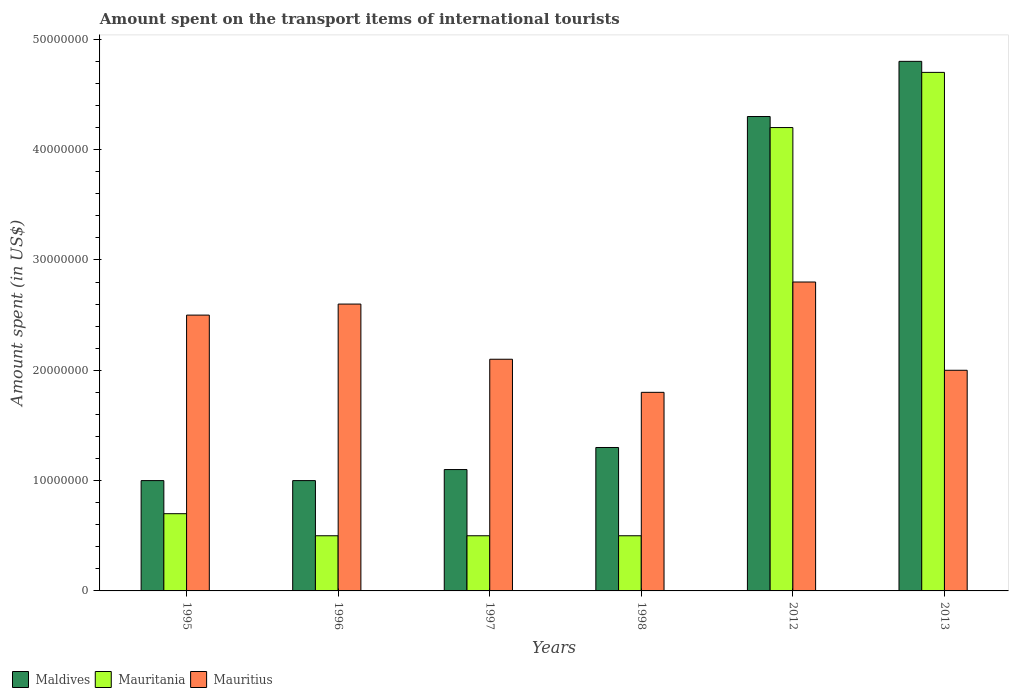Are the number of bars per tick equal to the number of legend labels?
Offer a terse response. Yes. Are the number of bars on each tick of the X-axis equal?
Make the answer very short. Yes. How many bars are there on the 2nd tick from the left?
Keep it short and to the point. 3. How many bars are there on the 3rd tick from the right?
Keep it short and to the point. 3. What is the label of the 5th group of bars from the left?
Your response must be concise. 2012. In how many cases, is the number of bars for a given year not equal to the number of legend labels?
Your answer should be compact. 0. What is the amount spent on the transport items of international tourists in Maldives in 2012?
Offer a terse response. 4.30e+07. Across all years, what is the maximum amount spent on the transport items of international tourists in Mauritius?
Provide a succinct answer. 2.80e+07. In which year was the amount spent on the transport items of international tourists in Mauritania maximum?
Your answer should be compact. 2013. In which year was the amount spent on the transport items of international tourists in Mauritania minimum?
Give a very brief answer. 1996. What is the total amount spent on the transport items of international tourists in Maldives in the graph?
Ensure brevity in your answer.  1.35e+08. What is the difference between the amount spent on the transport items of international tourists in Mauritania in 1998 and that in 2013?
Offer a terse response. -4.20e+07. What is the difference between the amount spent on the transport items of international tourists in Maldives in 2012 and the amount spent on the transport items of international tourists in Mauritius in 1995?
Your response must be concise. 1.80e+07. What is the average amount spent on the transport items of international tourists in Mauritania per year?
Keep it short and to the point. 1.85e+07. In the year 1995, what is the difference between the amount spent on the transport items of international tourists in Maldives and amount spent on the transport items of international tourists in Mauritius?
Make the answer very short. -1.50e+07. In how many years, is the amount spent on the transport items of international tourists in Maldives greater than 16000000 US$?
Your answer should be compact. 2. What is the ratio of the amount spent on the transport items of international tourists in Mauritania in 1996 to that in 2013?
Your answer should be compact. 0.11. Is the amount spent on the transport items of international tourists in Mauritania in 1995 less than that in 1996?
Give a very brief answer. No. What is the difference between the highest and the second highest amount spent on the transport items of international tourists in Mauritania?
Provide a short and direct response. 5.00e+06. What is the difference between the highest and the lowest amount spent on the transport items of international tourists in Mauritius?
Your answer should be compact. 1.00e+07. In how many years, is the amount spent on the transport items of international tourists in Mauritius greater than the average amount spent on the transport items of international tourists in Mauritius taken over all years?
Make the answer very short. 3. Is the sum of the amount spent on the transport items of international tourists in Mauritius in 1996 and 1997 greater than the maximum amount spent on the transport items of international tourists in Maldives across all years?
Your answer should be very brief. No. What does the 1st bar from the left in 1996 represents?
Your answer should be compact. Maldives. What does the 3rd bar from the right in 1995 represents?
Provide a short and direct response. Maldives. How many bars are there?
Provide a short and direct response. 18. What is the difference between two consecutive major ticks on the Y-axis?
Your answer should be very brief. 1.00e+07. Does the graph contain any zero values?
Make the answer very short. No. Does the graph contain grids?
Provide a short and direct response. No. Where does the legend appear in the graph?
Offer a very short reply. Bottom left. What is the title of the graph?
Offer a terse response. Amount spent on the transport items of international tourists. Does "Kenya" appear as one of the legend labels in the graph?
Give a very brief answer. No. What is the label or title of the X-axis?
Provide a succinct answer. Years. What is the label or title of the Y-axis?
Your response must be concise. Amount spent (in US$). What is the Amount spent (in US$) of Mauritius in 1995?
Your answer should be very brief. 2.50e+07. What is the Amount spent (in US$) of Maldives in 1996?
Make the answer very short. 1.00e+07. What is the Amount spent (in US$) of Mauritania in 1996?
Provide a succinct answer. 5.00e+06. What is the Amount spent (in US$) of Mauritius in 1996?
Keep it short and to the point. 2.60e+07. What is the Amount spent (in US$) in Maldives in 1997?
Offer a terse response. 1.10e+07. What is the Amount spent (in US$) of Mauritania in 1997?
Your response must be concise. 5.00e+06. What is the Amount spent (in US$) of Mauritius in 1997?
Offer a very short reply. 2.10e+07. What is the Amount spent (in US$) of Maldives in 1998?
Ensure brevity in your answer.  1.30e+07. What is the Amount spent (in US$) in Mauritania in 1998?
Make the answer very short. 5.00e+06. What is the Amount spent (in US$) in Mauritius in 1998?
Your answer should be very brief. 1.80e+07. What is the Amount spent (in US$) of Maldives in 2012?
Your answer should be very brief. 4.30e+07. What is the Amount spent (in US$) in Mauritania in 2012?
Your answer should be very brief. 4.20e+07. What is the Amount spent (in US$) in Mauritius in 2012?
Provide a succinct answer. 2.80e+07. What is the Amount spent (in US$) of Maldives in 2013?
Make the answer very short. 4.80e+07. What is the Amount spent (in US$) of Mauritania in 2013?
Keep it short and to the point. 4.70e+07. Across all years, what is the maximum Amount spent (in US$) in Maldives?
Ensure brevity in your answer.  4.80e+07. Across all years, what is the maximum Amount spent (in US$) in Mauritania?
Provide a short and direct response. 4.70e+07. Across all years, what is the maximum Amount spent (in US$) of Mauritius?
Give a very brief answer. 2.80e+07. Across all years, what is the minimum Amount spent (in US$) of Mauritius?
Offer a very short reply. 1.80e+07. What is the total Amount spent (in US$) in Maldives in the graph?
Keep it short and to the point. 1.35e+08. What is the total Amount spent (in US$) in Mauritania in the graph?
Keep it short and to the point. 1.11e+08. What is the total Amount spent (in US$) of Mauritius in the graph?
Your answer should be very brief. 1.38e+08. What is the difference between the Amount spent (in US$) of Maldives in 1995 and that in 1996?
Your answer should be compact. 0. What is the difference between the Amount spent (in US$) of Mauritania in 1995 and that in 1996?
Your answer should be very brief. 2.00e+06. What is the difference between the Amount spent (in US$) of Mauritius in 1995 and that in 1996?
Offer a very short reply. -1.00e+06. What is the difference between the Amount spent (in US$) in Mauritania in 1995 and that in 1997?
Offer a very short reply. 2.00e+06. What is the difference between the Amount spent (in US$) in Mauritius in 1995 and that in 1997?
Provide a succinct answer. 4.00e+06. What is the difference between the Amount spent (in US$) of Maldives in 1995 and that in 2012?
Your answer should be very brief. -3.30e+07. What is the difference between the Amount spent (in US$) of Mauritania in 1995 and that in 2012?
Provide a succinct answer. -3.50e+07. What is the difference between the Amount spent (in US$) of Mauritius in 1995 and that in 2012?
Your answer should be compact. -3.00e+06. What is the difference between the Amount spent (in US$) of Maldives in 1995 and that in 2013?
Give a very brief answer. -3.80e+07. What is the difference between the Amount spent (in US$) of Mauritania in 1995 and that in 2013?
Keep it short and to the point. -4.00e+07. What is the difference between the Amount spent (in US$) in Mauritania in 1996 and that in 1997?
Offer a terse response. 0. What is the difference between the Amount spent (in US$) of Mauritius in 1996 and that in 1997?
Your answer should be compact. 5.00e+06. What is the difference between the Amount spent (in US$) in Maldives in 1996 and that in 2012?
Ensure brevity in your answer.  -3.30e+07. What is the difference between the Amount spent (in US$) in Mauritania in 1996 and that in 2012?
Your answer should be compact. -3.70e+07. What is the difference between the Amount spent (in US$) in Maldives in 1996 and that in 2013?
Your answer should be very brief. -3.80e+07. What is the difference between the Amount spent (in US$) of Mauritania in 1996 and that in 2013?
Your response must be concise. -4.20e+07. What is the difference between the Amount spent (in US$) in Maldives in 1997 and that in 1998?
Provide a succinct answer. -2.00e+06. What is the difference between the Amount spent (in US$) in Mauritius in 1997 and that in 1998?
Give a very brief answer. 3.00e+06. What is the difference between the Amount spent (in US$) in Maldives in 1997 and that in 2012?
Make the answer very short. -3.20e+07. What is the difference between the Amount spent (in US$) of Mauritania in 1997 and that in 2012?
Offer a terse response. -3.70e+07. What is the difference between the Amount spent (in US$) of Mauritius in 1997 and that in 2012?
Keep it short and to the point. -7.00e+06. What is the difference between the Amount spent (in US$) in Maldives in 1997 and that in 2013?
Give a very brief answer. -3.70e+07. What is the difference between the Amount spent (in US$) of Mauritania in 1997 and that in 2013?
Offer a terse response. -4.20e+07. What is the difference between the Amount spent (in US$) in Maldives in 1998 and that in 2012?
Ensure brevity in your answer.  -3.00e+07. What is the difference between the Amount spent (in US$) in Mauritania in 1998 and that in 2012?
Provide a succinct answer. -3.70e+07. What is the difference between the Amount spent (in US$) of Mauritius in 1998 and that in 2012?
Make the answer very short. -1.00e+07. What is the difference between the Amount spent (in US$) of Maldives in 1998 and that in 2013?
Give a very brief answer. -3.50e+07. What is the difference between the Amount spent (in US$) in Mauritania in 1998 and that in 2013?
Your answer should be compact. -4.20e+07. What is the difference between the Amount spent (in US$) in Mauritius in 1998 and that in 2013?
Provide a succinct answer. -2.00e+06. What is the difference between the Amount spent (in US$) of Maldives in 2012 and that in 2013?
Keep it short and to the point. -5.00e+06. What is the difference between the Amount spent (in US$) in Mauritania in 2012 and that in 2013?
Offer a terse response. -5.00e+06. What is the difference between the Amount spent (in US$) in Mauritius in 2012 and that in 2013?
Offer a very short reply. 8.00e+06. What is the difference between the Amount spent (in US$) of Maldives in 1995 and the Amount spent (in US$) of Mauritius in 1996?
Provide a short and direct response. -1.60e+07. What is the difference between the Amount spent (in US$) in Mauritania in 1995 and the Amount spent (in US$) in Mauritius in 1996?
Make the answer very short. -1.90e+07. What is the difference between the Amount spent (in US$) of Maldives in 1995 and the Amount spent (in US$) of Mauritania in 1997?
Your answer should be compact. 5.00e+06. What is the difference between the Amount spent (in US$) of Maldives in 1995 and the Amount spent (in US$) of Mauritius in 1997?
Offer a terse response. -1.10e+07. What is the difference between the Amount spent (in US$) in Mauritania in 1995 and the Amount spent (in US$) in Mauritius in 1997?
Your response must be concise. -1.40e+07. What is the difference between the Amount spent (in US$) of Maldives in 1995 and the Amount spent (in US$) of Mauritius in 1998?
Give a very brief answer. -8.00e+06. What is the difference between the Amount spent (in US$) of Mauritania in 1995 and the Amount spent (in US$) of Mauritius in 1998?
Provide a succinct answer. -1.10e+07. What is the difference between the Amount spent (in US$) in Maldives in 1995 and the Amount spent (in US$) in Mauritania in 2012?
Make the answer very short. -3.20e+07. What is the difference between the Amount spent (in US$) of Maldives in 1995 and the Amount spent (in US$) of Mauritius in 2012?
Your response must be concise. -1.80e+07. What is the difference between the Amount spent (in US$) of Mauritania in 1995 and the Amount spent (in US$) of Mauritius in 2012?
Make the answer very short. -2.10e+07. What is the difference between the Amount spent (in US$) of Maldives in 1995 and the Amount spent (in US$) of Mauritania in 2013?
Your answer should be compact. -3.70e+07. What is the difference between the Amount spent (in US$) of Maldives in 1995 and the Amount spent (in US$) of Mauritius in 2013?
Make the answer very short. -1.00e+07. What is the difference between the Amount spent (in US$) in Mauritania in 1995 and the Amount spent (in US$) in Mauritius in 2013?
Your answer should be compact. -1.30e+07. What is the difference between the Amount spent (in US$) of Maldives in 1996 and the Amount spent (in US$) of Mauritius in 1997?
Give a very brief answer. -1.10e+07. What is the difference between the Amount spent (in US$) of Mauritania in 1996 and the Amount spent (in US$) of Mauritius in 1997?
Provide a short and direct response. -1.60e+07. What is the difference between the Amount spent (in US$) of Maldives in 1996 and the Amount spent (in US$) of Mauritania in 1998?
Make the answer very short. 5.00e+06. What is the difference between the Amount spent (in US$) of Maldives in 1996 and the Amount spent (in US$) of Mauritius in 1998?
Make the answer very short. -8.00e+06. What is the difference between the Amount spent (in US$) in Mauritania in 1996 and the Amount spent (in US$) in Mauritius in 1998?
Provide a succinct answer. -1.30e+07. What is the difference between the Amount spent (in US$) of Maldives in 1996 and the Amount spent (in US$) of Mauritania in 2012?
Your answer should be very brief. -3.20e+07. What is the difference between the Amount spent (in US$) in Maldives in 1996 and the Amount spent (in US$) in Mauritius in 2012?
Provide a succinct answer. -1.80e+07. What is the difference between the Amount spent (in US$) of Mauritania in 1996 and the Amount spent (in US$) of Mauritius in 2012?
Ensure brevity in your answer.  -2.30e+07. What is the difference between the Amount spent (in US$) of Maldives in 1996 and the Amount spent (in US$) of Mauritania in 2013?
Provide a succinct answer. -3.70e+07. What is the difference between the Amount spent (in US$) of Maldives in 1996 and the Amount spent (in US$) of Mauritius in 2013?
Make the answer very short. -1.00e+07. What is the difference between the Amount spent (in US$) in Mauritania in 1996 and the Amount spent (in US$) in Mauritius in 2013?
Your answer should be very brief. -1.50e+07. What is the difference between the Amount spent (in US$) of Maldives in 1997 and the Amount spent (in US$) of Mauritius in 1998?
Keep it short and to the point. -7.00e+06. What is the difference between the Amount spent (in US$) of Mauritania in 1997 and the Amount spent (in US$) of Mauritius in 1998?
Your answer should be compact. -1.30e+07. What is the difference between the Amount spent (in US$) in Maldives in 1997 and the Amount spent (in US$) in Mauritania in 2012?
Offer a terse response. -3.10e+07. What is the difference between the Amount spent (in US$) of Maldives in 1997 and the Amount spent (in US$) of Mauritius in 2012?
Keep it short and to the point. -1.70e+07. What is the difference between the Amount spent (in US$) in Mauritania in 1997 and the Amount spent (in US$) in Mauritius in 2012?
Offer a very short reply. -2.30e+07. What is the difference between the Amount spent (in US$) in Maldives in 1997 and the Amount spent (in US$) in Mauritania in 2013?
Offer a terse response. -3.60e+07. What is the difference between the Amount spent (in US$) in Maldives in 1997 and the Amount spent (in US$) in Mauritius in 2013?
Offer a terse response. -9.00e+06. What is the difference between the Amount spent (in US$) of Mauritania in 1997 and the Amount spent (in US$) of Mauritius in 2013?
Make the answer very short. -1.50e+07. What is the difference between the Amount spent (in US$) of Maldives in 1998 and the Amount spent (in US$) of Mauritania in 2012?
Your answer should be very brief. -2.90e+07. What is the difference between the Amount spent (in US$) of Maldives in 1998 and the Amount spent (in US$) of Mauritius in 2012?
Provide a succinct answer. -1.50e+07. What is the difference between the Amount spent (in US$) of Mauritania in 1998 and the Amount spent (in US$) of Mauritius in 2012?
Your answer should be very brief. -2.30e+07. What is the difference between the Amount spent (in US$) in Maldives in 1998 and the Amount spent (in US$) in Mauritania in 2013?
Your response must be concise. -3.40e+07. What is the difference between the Amount spent (in US$) of Maldives in 1998 and the Amount spent (in US$) of Mauritius in 2013?
Provide a short and direct response. -7.00e+06. What is the difference between the Amount spent (in US$) in Mauritania in 1998 and the Amount spent (in US$) in Mauritius in 2013?
Your answer should be very brief. -1.50e+07. What is the difference between the Amount spent (in US$) in Maldives in 2012 and the Amount spent (in US$) in Mauritania in 2013?
Offer a terse response. -4.00e+06. What is the difference between the Amount spent (in US$) of Maldives in 2012 and the Amount spent (in US$) of Mauritius in 2013?
Offer a terse response. 2.30e+07. What is the difference between the Amount spent (in US$) in Mauritania in 2012 and the Amount spent (in US$) in Mauritius in 2013?
Keep it short and to the point. 2.20e+07. What is the average Amount spent (in US$) in Maldives per year?
Offer a very short reply. 2.25e+07. What is the average Amount spent (in US$) of Mauritania per year?
Your response must be concise. 1.85e+07. What is the average Amount spent (in US$) of Mauritius per year?
Keep it short and to the point. 2.30e+07. In the year 1995, what is the difference between the Amount spent (in US$) of Maldives and Amount spent (in US$) of Mauritius?
Keep it short and to the point. -1.50e+07. In the year 1995, what is the difference between the Amount spent (in US$) of Mauritania and Amount spent (in US$) of Mauritius?
Keep it short and to the point. -1.80e+07. In the year 1996, what is the difference between the Amount spent (in US$) of Maldives and Amount spent (in US$) of Mauritius?
Offer a terse response. -1.60e+07. In the year 1996, what is the difference between the Amount spent (in US$) of Mauritania and Amount spent (in US$) of Mauritius?
Your answer should be compact. -2.10e+07. In the year 1997, what is the difference between the Amount spent (in US$) of Maldives and Amount spent (in US$) of Mauritius?
Make the answer very short. -1.00e+07. In the year 1997, what is the difference between the Amount spent (in US$) in Mauritania and Amount spent (in US$) in Mauritius?
Ensure brevity in your answer.  -1.60e+07. In the year 1998, what is the difference between the Amount spent (in US$) in Maldives and Amount spent (in US$) in Mauritius?
Your answer should be very brief. -5.00e+06. In the year 1998, what is the difference between the Amount spent (in US$) in Mauritania and Amount spent (in US$) in Mauritius?
Keep it short and to the point. -1.30e+07. In the year 2012, what is the difference between the Amount spent (in US$) of Maldives and Amount spent (in US$) of Mauritius?
Offer a very short reply. 1.50e+07. In the year 2012, what is the difference between the Amount spent (in US$) of Mauritania and Amount spent (in US$) of Mauritius?
Your answer should be very brief. 1.40e+07. In the year 2013, what is the difference between the Amount spent (in US$) of Maldives and Amount spent (in US$) of Mauritius?
Keep it short and to the point. 2.80e+07. In the year 2013, what is the difference between the Amount spent (in US$) in Mauritania and Amount spent (in US$) in Mauritius?
Your answer should be compact. 2.70e+07. What is the ratio of the Amount spent (in US$) in Mauritania in 1995 to that in 1996?
Keep it short and to the point. 1.4. What is the ratio of the Amount spent (in US$) in Mauritius in 1995 to that in 1996?
Your answer should be very brief. 0.96. What is the ratio of the Amount spent (in US$) of Mauritania in 1995 to that in 1997?
Give a very brief answer. 1.4. What is the ratio of the Amount spent (in US$) in Mauritius in 1995 to that in 1997?
Make the answer very short. 1.19. What is the ratio of the Amount spent (in US$) in Maldives in 1995 to that in 1998?
Keep it short and to the point. 0.77. What is the ratio of the Amount spent (in US$) of Mauritania in 1995 to that in 1998?
Offer a terse response. 1.4. What is the ratio of the Amount spent (in US$) of Mauritius in 1995 to that in 1998?
Provide a short and direct response. 1.39. What is the ratio of the Amount spent (in US$) in Maldives in 1995 to that in 2012?
Your answer should be compact. 0.23. What is the ratio of the Amount spent (in US$) of Mauritania in 1995 to that in 2012?
Give a very brief answer. 0.17. What is the ratio of the Amount spent (in US$) of Mauritius in 1995 to that in 2012?
Your answer should be very brief. 0.89. What is the ratio of the Amount spent (in US$) in Maldives in 1995 to that in 2013?
Provide a succinct answer. 0.21. What is the ratio of the Amount spent (in US$) of Mauritania in 1995 to that in 2013?
Keep it short and to the point. 0.15. What is the ratio of the Amount spent (in US$) in Mauritania in 1996 to that in 1997?
Offer a terse response. 1. What is the ratio of the Amount spent (in US$) of Mauritius in 1996 to that in 1997?
Provide a succinct answer. 1.24. What is the ratio of the Amount spent (in US$) of Maldives in 1996 to that in 1998?
Ensure brevity in your answer.  0.77. What is the ratio of the Amount spent (in US$) of Mauritius in 1996 to that in 1998?
Provide a succinct answer. 1.44. What is the ratio of the Amount spent (in US$) of Maldives in 1996 to that in 2012?
Your answer should be very brief. 0.23. What is the ratio of the Amount spent (in US$) in Mauritania in 1996 to that in 2012?
Provide a succinct answer. 0.12. What is the ratio of the Amount spent (in US$) in Maldives in 1996 to that in 2013?
Provide a succinct answer. 0.21. What is the ratio of the Amount spent (in US$) of Mauritania in 1996 to that in 2013?
Ensure brevity in your answer.  0.11. What is the ratio of the Amount spent (in US$) in Maldives in 1997 to that in 1998?
Make the answer very short. 0.85. What is the ratio of the Amount spent (in US$) of Mauritius in 1997 to that in 1998?
Provide a short and direct response. 1.17. What is the ratio of the Amount spent (in US$) in Maldives in 1997 to that in 2012?
Keep it short and to the point. 0.26. What is the ratio of the Amount spent (in US$) of Mauritania in 1997 to that in 2012?
Your response must be concise. 0.12. What is the ratio of the Amount spent (in US$) in Maldives in 1997 to that in 2013?
Your answer should be compact. 0.23. What is the ratio of the Amount spent (in US$) in Mauritania in 1997 to that in 2013?
Make the answer very short. 0.11. What is the ratio of the Amount spent (in US$) in Maldives in 1998 to that in 2012?
Make the answer very short. 0.3. What is the ratio of the Amount spent (in US$) in Mauritania in 1998 to that in 2012?
Give a very brief answer. 0.12. What is the ratio of the Amount spent (in US$) of Mauritius in 1998 to that in 2012?
Keep it short and to the point. 0.64. What is the ratio of the Amount spent (in US$) of Maldives in 1998 to that in 2013?
Your answer should be compact. 0.27. What is the ratio of the Amount spent (in US$) of Mauritania in 1998 to that in 2013?
Give a very brief answer. 0.11. What is the ratio of the Amount spent (in US$) in Maldives in 2012 to that in 2013?
Your answer should be very brief. 0.9. What is the ratio of the Amount spent (in US$) of Mauritania in 2012 to that in 2013?
Make the answer very short. 0.89. What is the ratio of the Amount spent (in US$) in Mauritius in 2012 to that in 2013?
Offer a terse response. 1.4. What is the difference between the highest and the second highest Amount spent (in US$) in Maldives?
Your response must be concise. 5.00e+06. What is the difference between the highest and the second highest Amount spent (in US$) of Mauritius?
Ensure brevity in your answer.  2.00e+06. What is the difference between the highest and the lowest Amount spent (in US$) in Maldives?
Make the answer very short. 3.80e+07. What is the difference between the highest and the lowest Amount spent (in US$) of Mauritania?
Keep it short and to the point. 4.20e+07. What is the difference between the highest and the lowest Amount spent (in US$) in Mauritius?
Your answer should be very brief. 1.00e+07. 